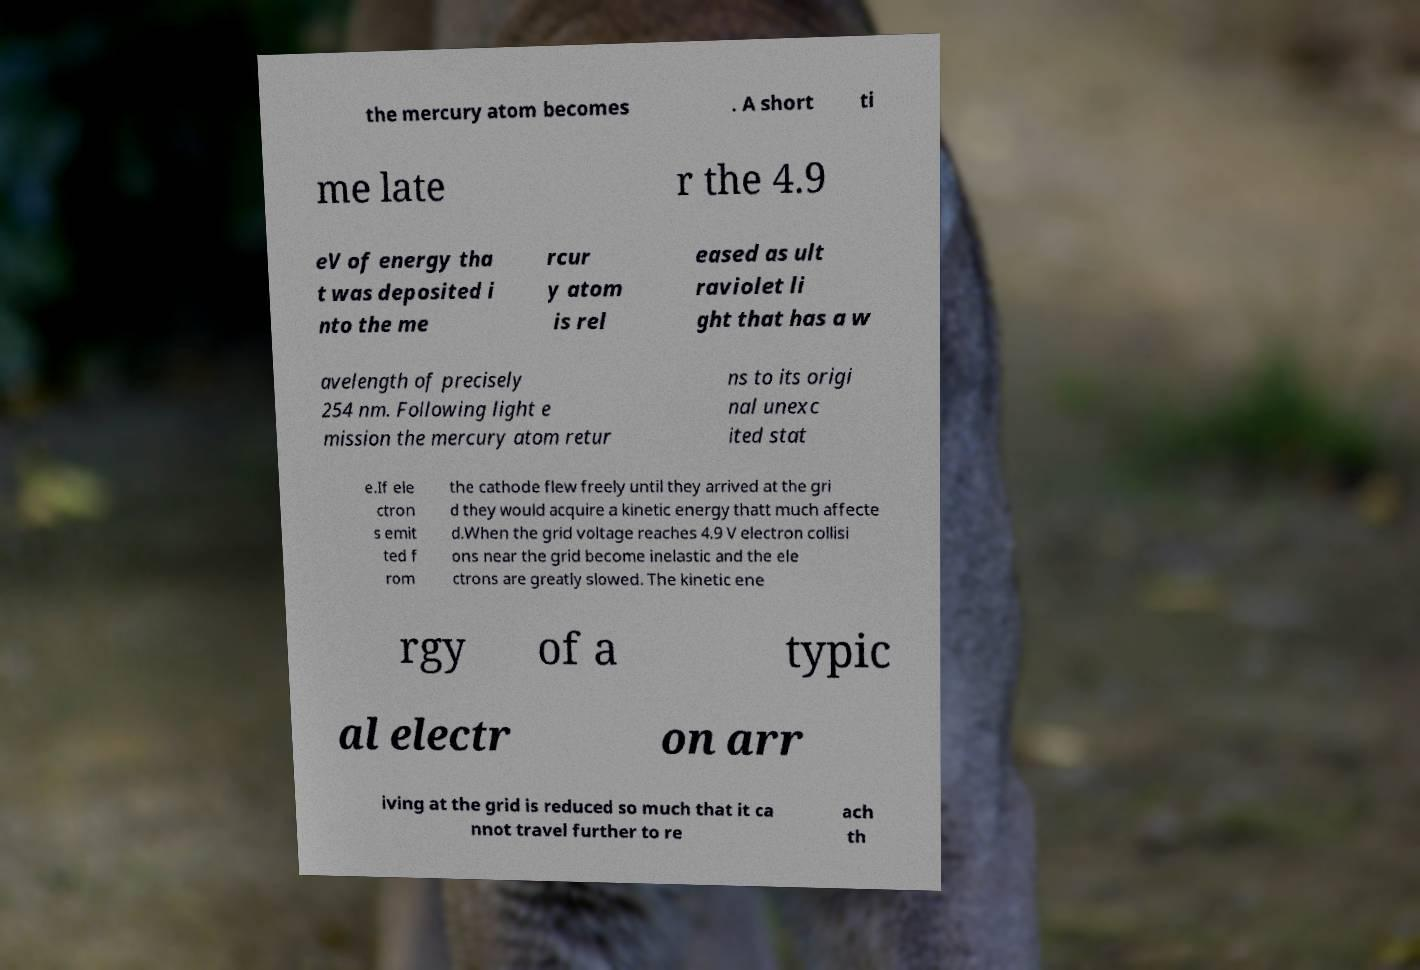I need the written content from this picture converted into text. Can you do that? the mercury atom becomes . A short ti me late r the 4.9 eV of energy tha t was deposited i nto the me rcur y atom is rel eased as ult raviolet li ght that has a w avelength of precisely 254 nm. Following light e mission the mercury atom retur ns to its origi nal unexc ited stat e.If ele ctron s emit ted f rom the cathode flew freely until they arrived at the gri d they would acquire a kinetic energy thatt much affecte d.When the grid voltage reaches 4.9 V electron collisi ons near the grid become inelastic and the ele ctrons are greatly slowed. The kinetic ene rgy of a typic al electr on arr iving at the grid is reduced so much that it ca nnot travel further to re ach th 